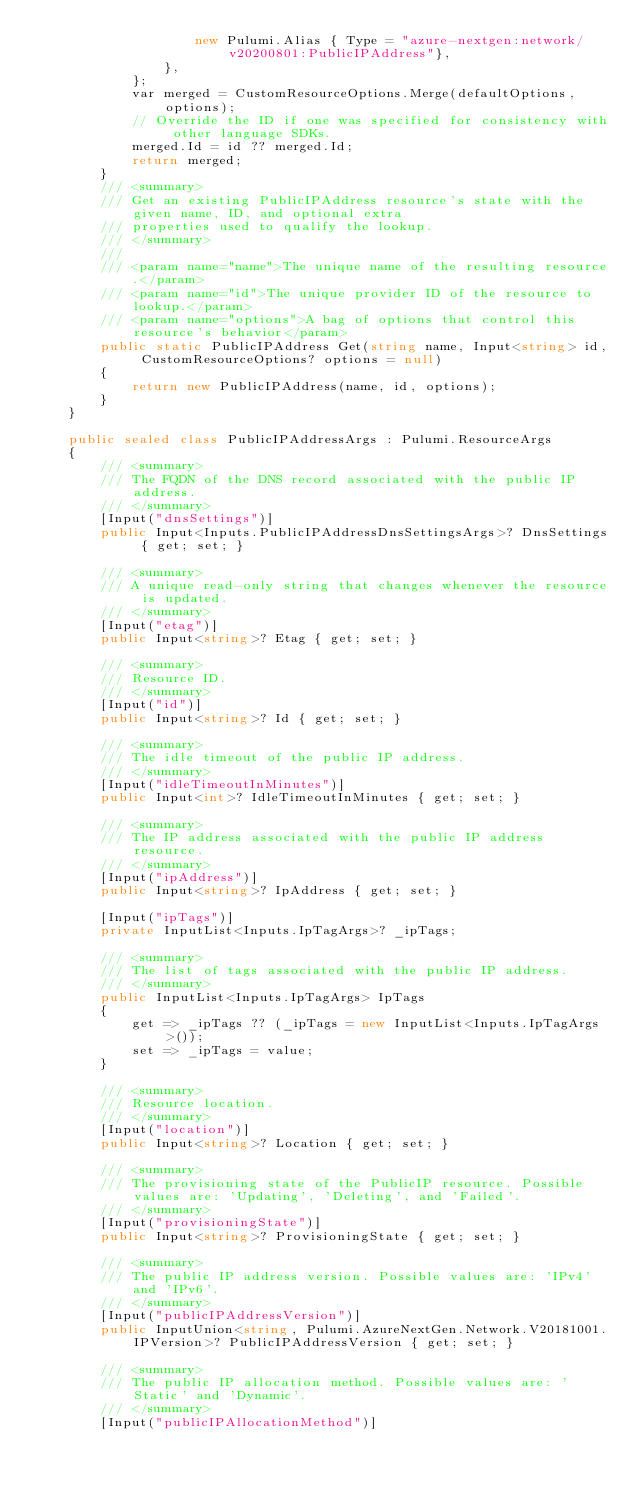Convert code to text. <code><loc_0><loc_0><loc_500><loc_500><_C#_>                    new Pulumi.Alias { Type = "azure-nextgen:network/v20200801:PublicIPAddress"},
                },
            };
            var merged = CustomResourceOptions.Merge(defaultOptions, options);
            // Override the ID if one was specified for consistency with other language SDKs.
            merged.Id = id ?? merged.Id;
            return merged;
        }
        /// <summary>
        /// Get an existing PublicIPAddress resource's state with the given name, ID, and optional extra
        /// properties used to qualify the lookup.
        /// </summary>
        ///
        /// <param name="name">The unique name of the resulting resource.</param>
        /// <param name="id">The unique provider ID of the resource to lookup.</param>
        /// <param name="options">A bag of options that control this resource's behavior</param>
        public static PublicIPAddress Get(string name, Input<string> id, CustomResourceOptions? options = null)
        {
            return new PublicIPAddress(name, id, options);
        }
    }

    public sealed class PublicIPAddressArgs : Pulumi.ResourceArgs
    {
        /// <summary>
        /// The FQDN of the DNS record associated with the public IP address.
        /// </summary>
        [Input("dnsSettings")]
        public Input<Inputs.PublicIPAddressDnsSettingsArgs>? DnsSettings { get; set; }

        /// <summary>
        /// A unique read-only string that changes whenever the resource is updated.
        /// </summary>
        [Input("etag")]
        public Input<string>? Etag { get; set; }

        /// <summary>
        /// Resource ID.
        /// </summary>
        [Input("id")]
        public Input<string>? Id { get; set; }

        /// <summary>
        /// The idle timeout of the public IP address.
        /// </summary>
        [Input("idleTimeoutInMinutes")]
        public Input<int>? IdleTimeoutInMinutes { get; set; }

        /// <summary>
        /// The IP address associated with the public IP address resource.
        /// </summary>
        [Input("ipAddress")]
        public Input<string>? IpAddress { get; set; }

        [Input("ipTags")]
        private InputList<Inputs.IpTagArgs>? _ipTags;

        /// <summary>
        /// The list of tags associated with the public IP address.
        /// </summary>
        public InputList<Inputs.IpTagArgs> IpTags
        {
            get => _ipTags ?? (_ipTags = new InputList<Inputs.IpTagArgs>());
            set => _ipTags = value;
        }

        /// <summary>
        /// Resource location.
        /// </summary>
        [Input("location")]
        public Input<string>? Location { get; set; }

        /// <summary>
        /// The provisioning state of the PublicIP resource. Possible values are: 'Updating', 'Deleting', and 'Failed'.
        /// </summary>
        [Input("provisioningState")]
        public Input<string>? ProvisioningState { get; set; }

        /// <summary>
        /// The public IP address version. Possible values are: 'IPv4' and 'IPv6'.
        /// </summary>
        [Input("publicIPAddressVersion")]
        public InputUnion<string, Pulumi.AzureNextGen.Network.V20181001.IPVersion>? PublicIPAddressVersion { get; set; }

        /// <summary>
        /// The public IP allocation method. Possible values are: 'Static' and 'Dynamic'.
        /// </summary>
        [Input("publicIPAllocationMethod")]</code> 